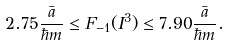<formula> <loc_0><loc_0><loc_500><loc_500>2 . 7 5 \frac { \bar { a } } { \hbar { m } } \leq F _ { - 1 } ( I ^ { 3 } ) \leq 7 . 9 0 \frac { \bar { a } } { \hbar { m } } .</formula> 